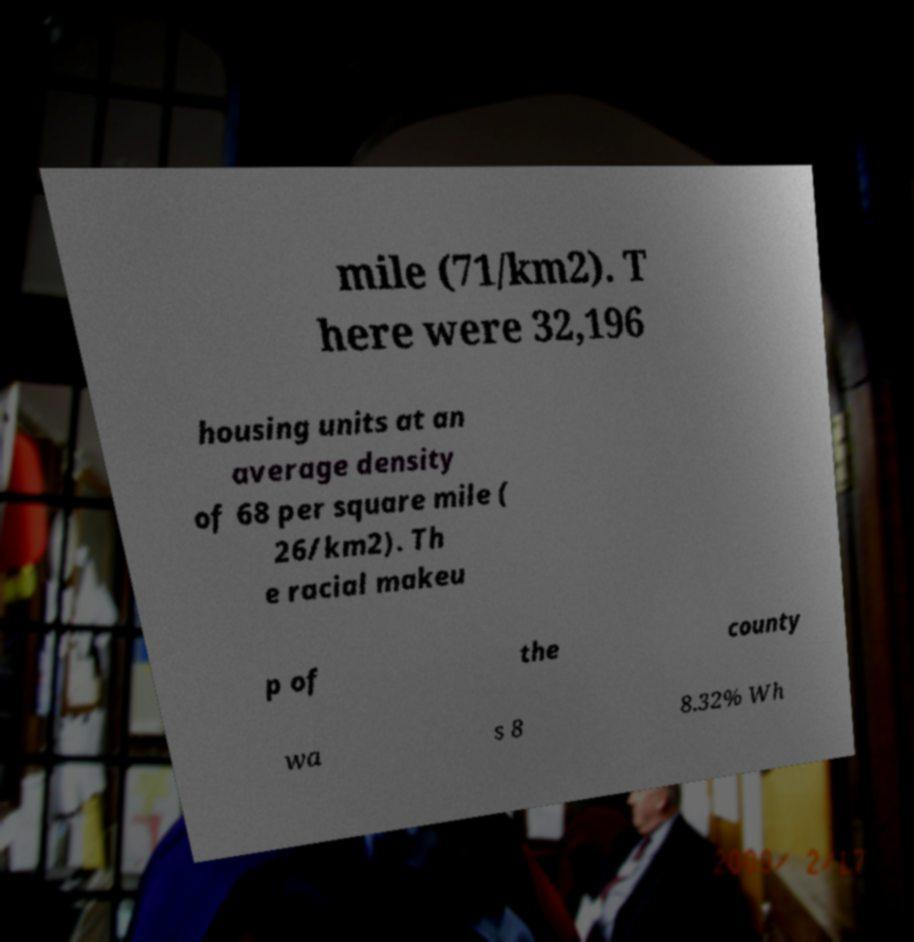What messages or text are displayed in this image? I need them in a readable, typed format. mile (71/km2). T here were 32,196 housing units at an average density of 68 per square mile ( 26/km2). Th e racial makeu p of the county wa s 8 8.32% Wh 